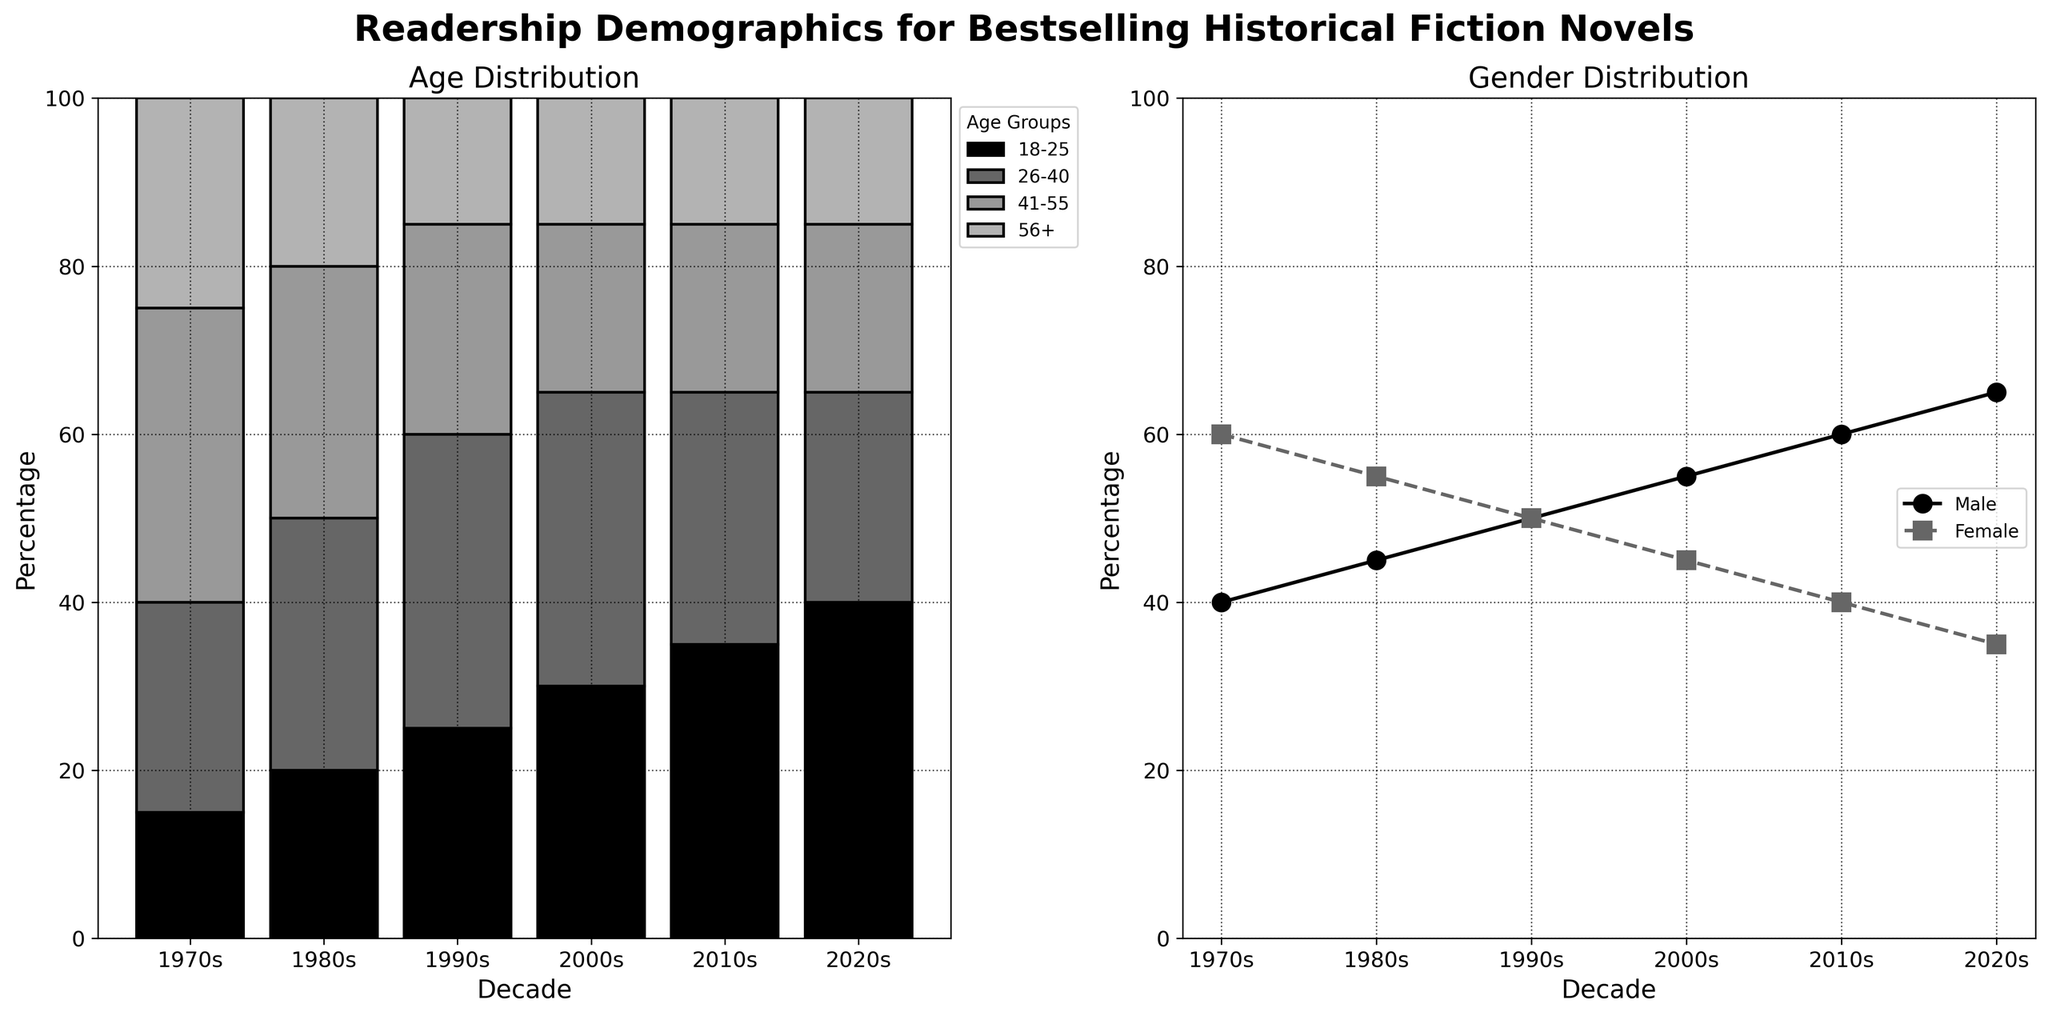What is the title of the first subplot? The title of the first subplot is displayed at the top of the left subplot. The text reads "Age Distribution."
Answer: Age Distribution In which decade did the male readership surpass female readership? By looking at the gender distribution plot, the male line surpasses the female line starting in the 2000s and continues past the 2010s and 2020s.
Answer: 2000s What was the percentage of readership in the 18-25 age group in the 1990s? To find the percentage of the 18-25 age group in the 1990s, refer to the bar labeled "1990s" in the age distribution subplot. The bar segment for the 18-25 group reaches up to 25%.
Answer: 25% Which age group saw the largest increase in readership from the 1970s to the 2020s? By comparing the heights of the bars for the 18-25 age group spans from 15% in the 1970s to 40% in the 2020s, demonstrating the largest increase of 25%.
Answer: 18-25 How does the female readership in the 2010s compare to that in the 1980s? Refer to the gender plot. The point corresponding to females in the 2010s is at 40%, while in the 1980s it is at 55%. Subtract these values to find the difference.
Answer: Female readership decreased by 15% What trends can you observe about the age group '56+' between the 1970s and the 2020s? Observing the '56+' category in the age distribution subplot, we see a decrease from 25% in the 1970s down to about 15% by the 2020s, indicating a downward trend.
Answer: Decreasing What percentage of the total readership was in the 26-40 age group in the 1980s? The height of the 26-40 segment in the 1980 bar can be read directly. It shows 30%.
Answer: 30% In which decade did both male and female readership equalize? Referring to the gender plot, the male and female lines intersect in the 1990s, showing equal readership at 50%.
Answer: 1990s Can you compare the total percentage of readers aged 41-55 in the 1970s and 2010s? In the age distribution subplot, the bar segment for 41-55 in the 1970s is 35%, and in the 2010s, it is 20%.
Answer: The percentage decreased by 15% How did the total readership in the 18-25 age group change from the 1970s to the 2020s? By comparing the heights of the 18-25 segments, we see it increased from 15% to 40%. The change is calculated as 40% - 15% = 25%.
Answer: It increased by 25% 